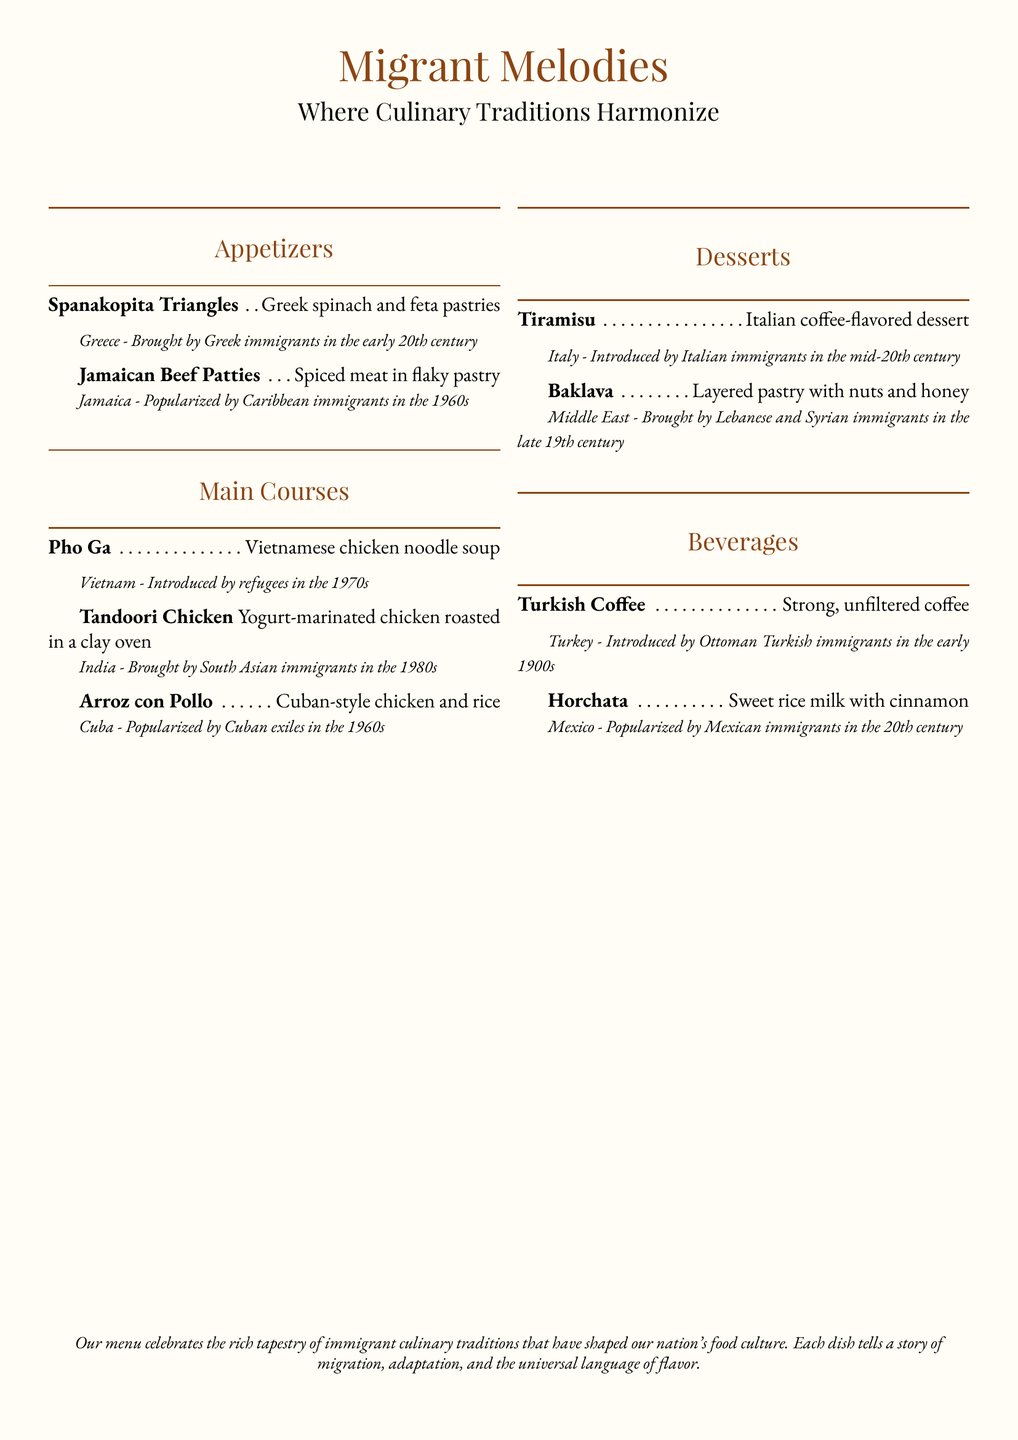What is the name of the restaurant? The restaurant is named "Migrant Melodies" as indicated at the top of the menu.
Answer: Migrant Melodies What type of cuisine does the restaurant feature? The restaurant features dishes inspired by immigrant communities, as stated in the subtitle.
Answer: Immigrant communities In which section would you find Spanakopita Triangles? Spanakopita Triangles are listed under the "Appetizers" section of the menu.
Answer: Appetizers When were Jamaican Beef Patties popularized? According to the menu, Jamaican Beef Patties were popularized by Caribbean immigrants in the 1960s.
Answer: 1960s What is the origin country of Pho Ga? Pho Ga is from Vietnam, as mentioned in the dish description.
Answer: Vietnam Which dish was introduced by Italian immigrants? The dish introduced by Italian immigrants is Tiramisu, specifically noted in the desserts section.
Answer: Tiramisu How many desserts are listed on the menu? There are two desserts listed on the menu: Tiramisu and Baklava.
Answer: Two What beverage originated from Turkey? Turkish Coffee is the beverage mentioned that originated from Turkey.
Answer: Turkish Coffee Which dish includes yogurt-marinated chicken? Tandoori Chicken is the dish that includes yogurt-marinated chicken.
Answer: Tandoori Chicken 